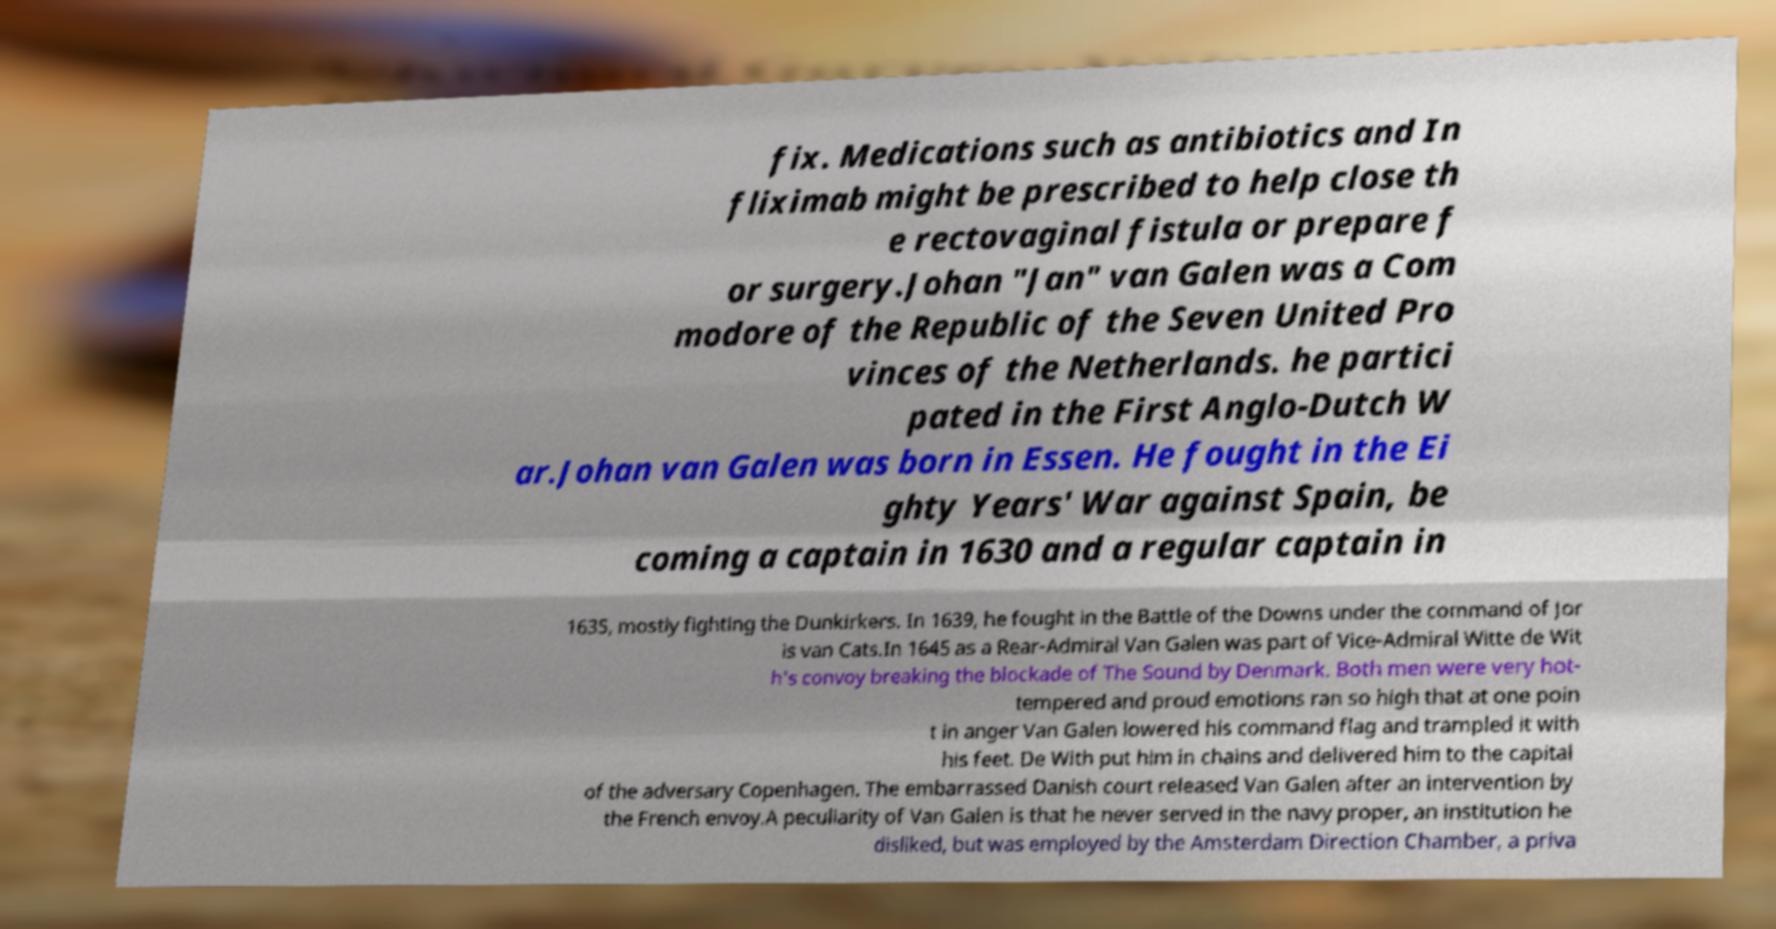What messages or text are displayed in this image? I need them in a readable, typed format. fix. Medications such as antibiotics and In fliximab might be prescribed to help close th e rectovaginal fistula or prepare f or surgery.Johan "Jan" van Galen was a Com modore of the Republic of the Seven United Pro vinces of the Netherlands. he partici pated in the First Anglo-Dutch W ar.Johan van Galen was born in Essen. He fought in the Ei ghty Years' War against Spain, be coming a captain in 1630 and a regular captain in 1635, mostly fighting the Dunkirkers. In 1639, he fought in the Battle of the Downs under the command of Jor is van Cats.In 1645 as a Rear-Admiral Van Galen was part of Vice-Admiral Witte de Wit h's convoy breaking the blockade of The Sound by Denmark. Both men were very hot- tempered and proud emotions ran so high that at one poin t in anger Van Galen lowered his command flag and trampled it with his feet. De With put him in chains and delivered him to the capital of the adversary Copenhagen. The embarrassed Danish court released Van Galen after an intervention by the French envoy.A peculiarity of Van Galen is that he never served in the navy proper, an institution he disliked, but was employed by the Amsterdam Direction Chamber, a priva 